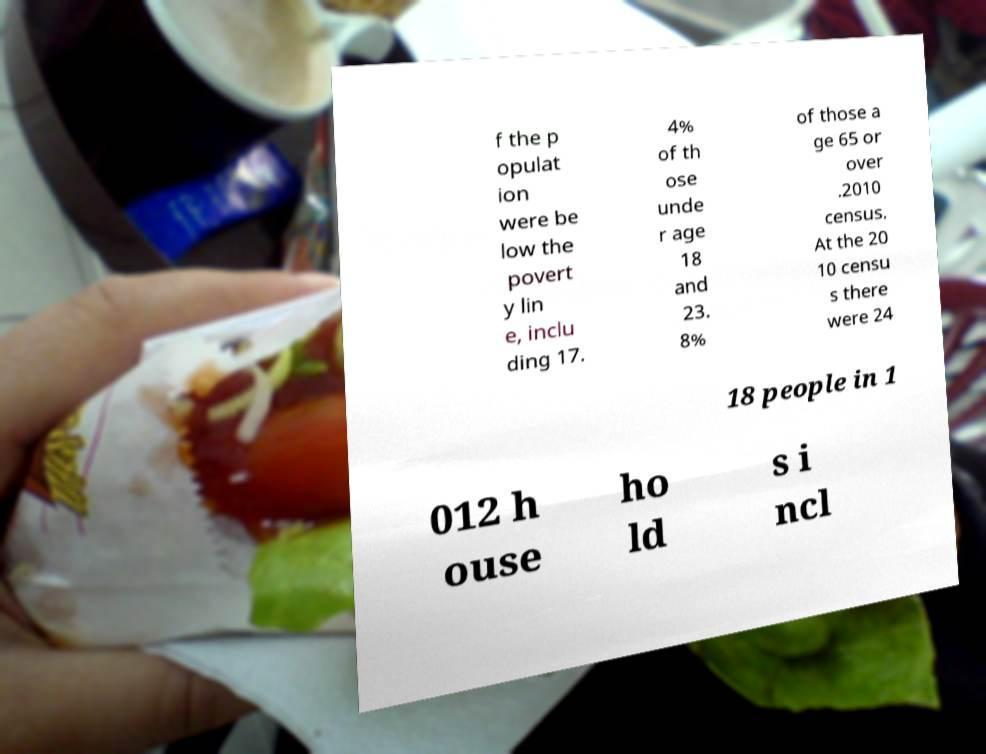Please identify and transcribe the text found in this image. f the p opulat ion were be low the povert y lin e, inclu ding 17. 4% of th ose unde r age 18 and 23. 8% of those a ge 65 or over .2010 census. At the 20 10 censu s there were 24 18 people in 1 012 h ouse ho ld s i ncl 